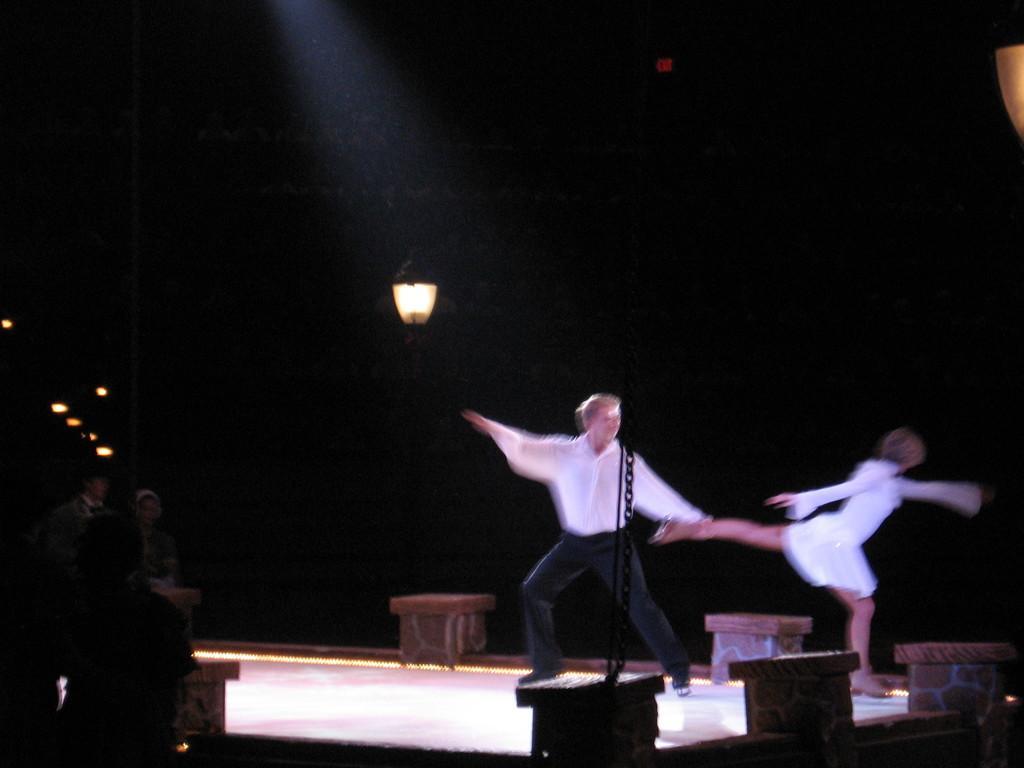Please provide a concise description of this image. In this image there are persons performing on the stage in the center. On the left side there are persons. At the top there is a light hanging. In the front there are walls and there is a black colour stand. 